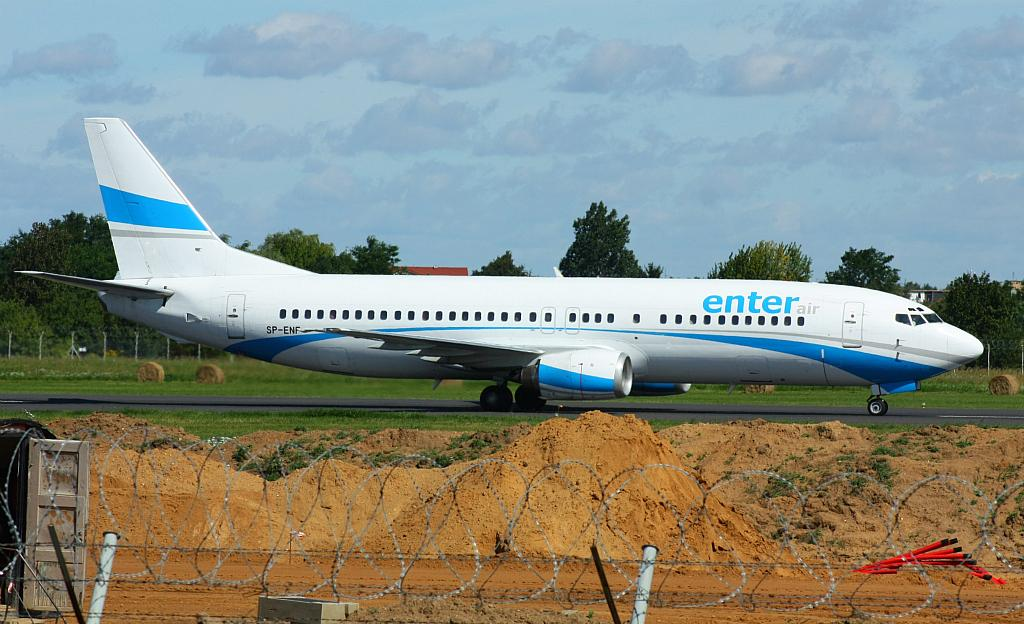<image>
Share a concise interpretation of the image provided. an Enter Air plane taxiing on a runway 